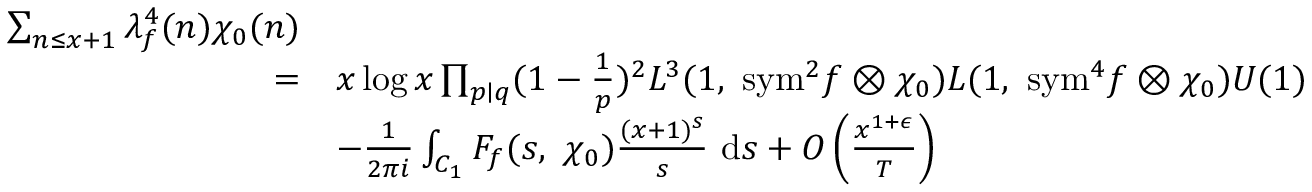<formula> <loc_0><loc_0><loc_500><loc_500>\begin{array} { r l } { \sum _ { n \leq x + 1 } \lambda _ { f } ^ { 4 } ( n ) \chi _ { 0 } ( n ) } \\ { = } & { x \log x \prod _ { p | q } ( 1 - \frac { 1 } { p } ) ^ { 2 } L ^ { 3 } ( 1 , \ { s y m } ^ { 2 } f \otimes \chi _ { 0 } ) L ( 1 , \ { s y m } ^ { 4 } f \otimes \chi _ { 0 } ) U ( 1 ) } \\ & { - \frac { 1 } { 2 \pi i } \int _ { C _ { 1 } } F _ { f } ( s , \ \chi _ { 0 } ) \frac { ( x + 1 ) ^ { s } } { s } \ d s + O \left ( \frac { x ^ { 1 + \epsilon } } { T } \right ) } \end{array}</formula> 